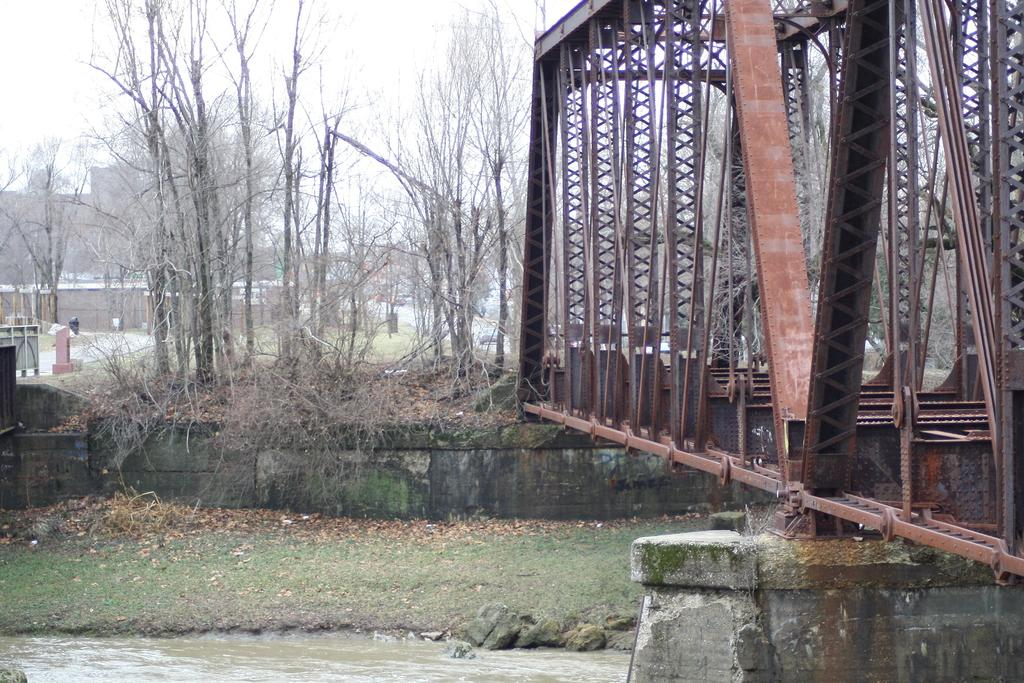What type of vegetation can be seen in the image? There are dry trees in the image. What structures are present in the image? There are buildings and a bridge in the image. What natural element is visible in the image? There is water visible in the image. What is present on the ground in the image? There are dry leaves in the image. What is the color of the sky in the image? The sky appears to be white in color. What advice does the uncle give in the image? There is no uncle present in the image, and therefore no advice can be given. What type of lock is visible on the bridge in the image? There is no lock visible on the bridge in the image. 